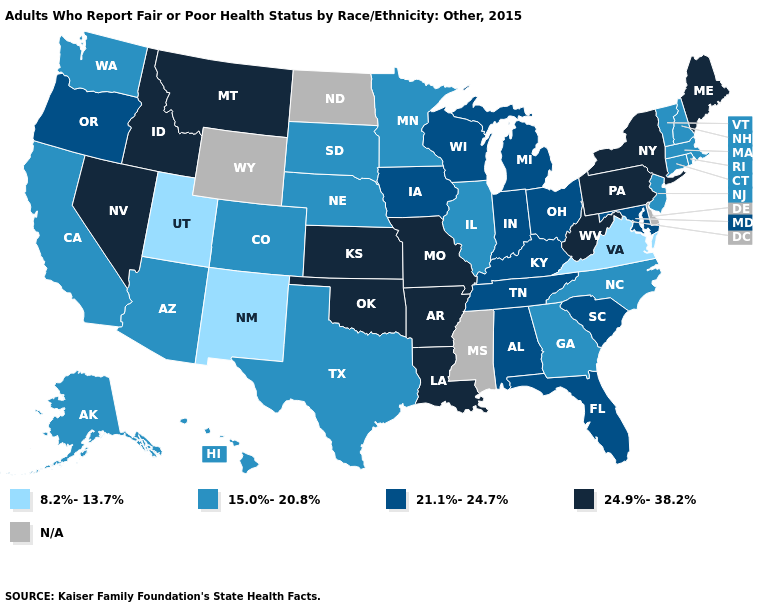Among the states that border Alabama , does Florida have the lowest value?
Keep it brief. No. Which states hav the highest value in the Northeast?
Answer briefly. Maine, New York, Pennsylvania. Which states hav the highest value in the MidWest?
Give a very brief answer. Kansas, Missouri. Which states have the lowest value in the South?
Be succinct. Virginia. Name the states that have a value in the range 8.2%-13.7%?
Write a very short answer. New Mexico, Utah, Virginia. Name the states that have a value in the range 24.9%-38.2%?
Short answer required. Arkansas, Idaho, Kansas, Louisiana, Maine, Missouri, Montana, Nevada, New York, Oklahoma, Pennsylvania, West Virginia. Does Pennsylvania have the highest value in the USA?
Answer briefly. Yes. What is the lowest value in the West?
Keep it brief. 8.2%-13.7%. Name the states that have a value in the range 24.9%-38.2%?
Short answer required. Arkansas, Idaho, Kansas, Louisiana, Maine, Missouri, Montana, Nevada, New York, Oklahoma, Pennsylvania, West Virginia. Name the states that have a value in the range 24.9%-38.2%?
Short answer required. Arkansas, Idaho, Kansas, Louisiana, Maine, Missouri, Montana, Nevada, New York, Oklahoma, Pennsylvania, West Virginia. How many symbols are there in the legend?
Give a very brief answer. 5. Does the map have missing data?
Answer briefly. Yes. Among the states that border Idaho , does Montana have the lowest value?
Keep it brief. No. Does Michigan have the highest value in the USA?
Quick response, please. No. 